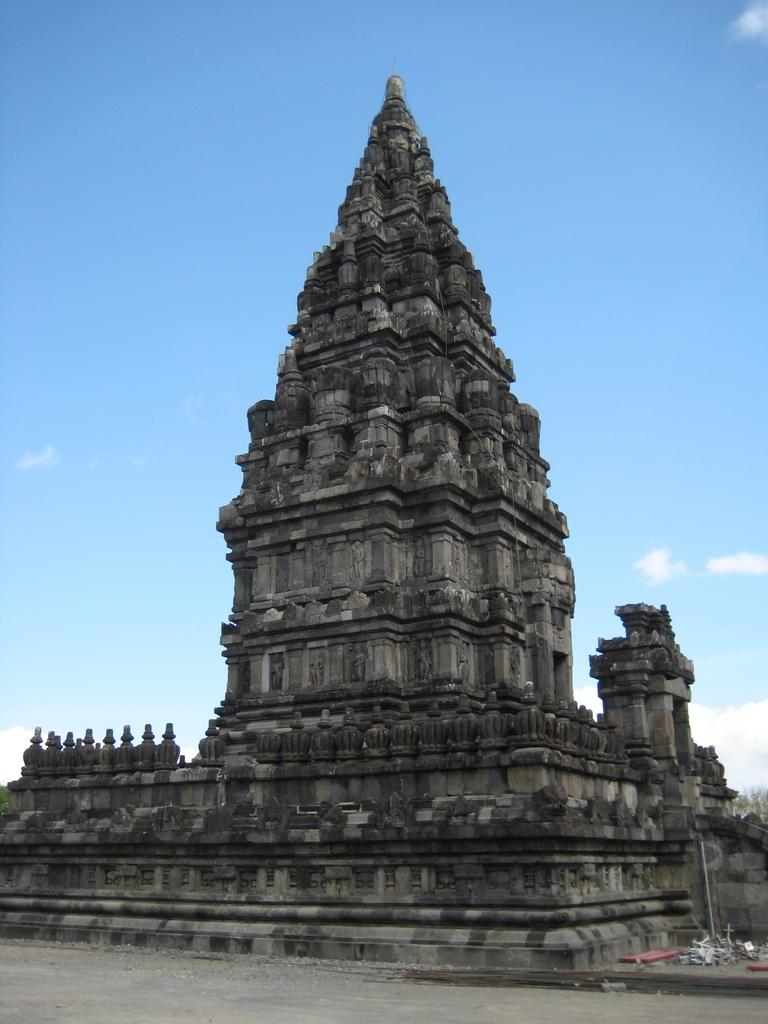What type of structure is in the picture? There is a temple in the picture. What else can be seen in the picture besides the temple? There are items and trees in the picture. What is visible in the background of the picture? The sky is visible in the background of the picture. What type of pencil is being used by the creator in the picture? There is no creator or pencil present in the picture; it features a temple, items, trees, and the sky. 